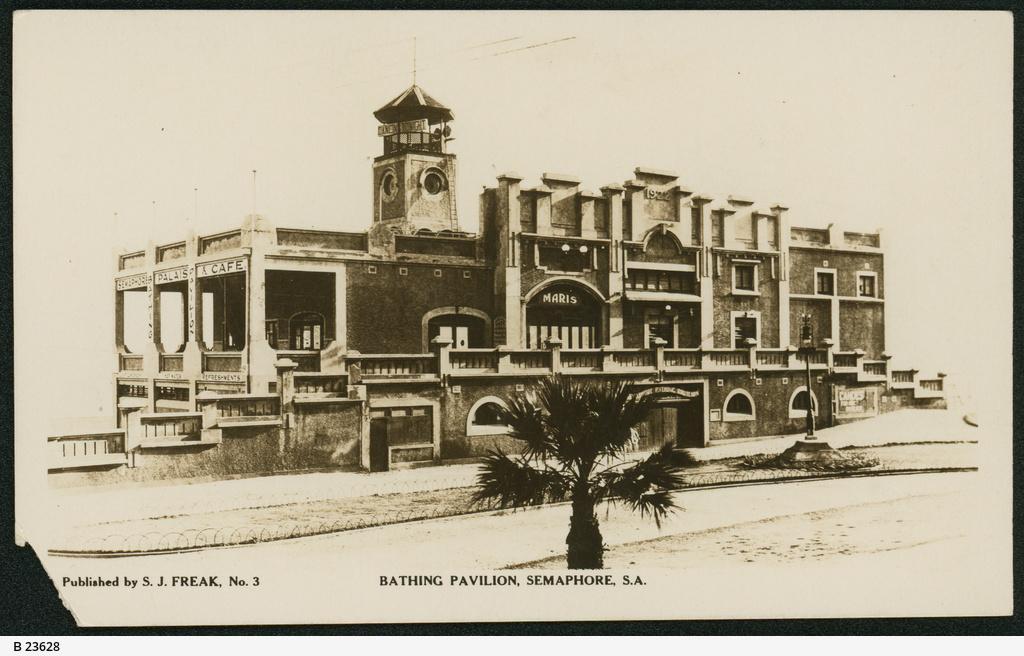How would you summarize this image in a sentence or two? This is black and white image. In this image we can see building, tree, road, street light. In the background there is sky. At the bottom we can see text. 